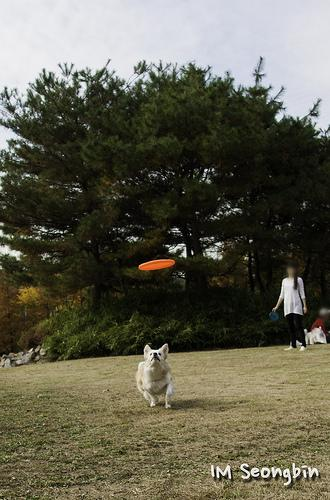Express the focus of the image using a short phrase. Playful frisbee game with dog in nature. What is the central interaction between the two main subjects in the image? A woman is holding a blue frisbee, and a dog is jumping to catch an orange frisbee in the air. Describe the environment in which the main subject is found. A woman and her dog are surrounded by a field of brown grass, bushes, trees, and a cloudy blue sky. Create a poetic line about the image using a metaphor. Dancing frisbees paint the skies, as joyful laughter echoes from the canine and its friend. Write a sentence describing the primary object in motion in the image. An orange frisbee is in the air, soaring towards a dog preparing to catch it. Mention the central activity taking place in the image. A girl playing frisbee with her dog in the park, while surrounded by different elements of nature. Mention the key elements located in the background of the image. Tall green pine tree, yellow leaf-filled tree, a bunch of green bushes, and a cloudy blue sky. Mention the main subject and their attire. A woman wearing a white top, black pants, and white shoes is holding a blue frisbee. Use a simile to describe the scene in the image. A woman and her dog play frisbee in the park, as lively as two children on a sunny day. Explain the image's context as if you're telling a brief story. On a beautiful day, a woman and her dog ventured out to a park filled with grass, bushes, and trees, happily tossing and chasing frisbees together. 